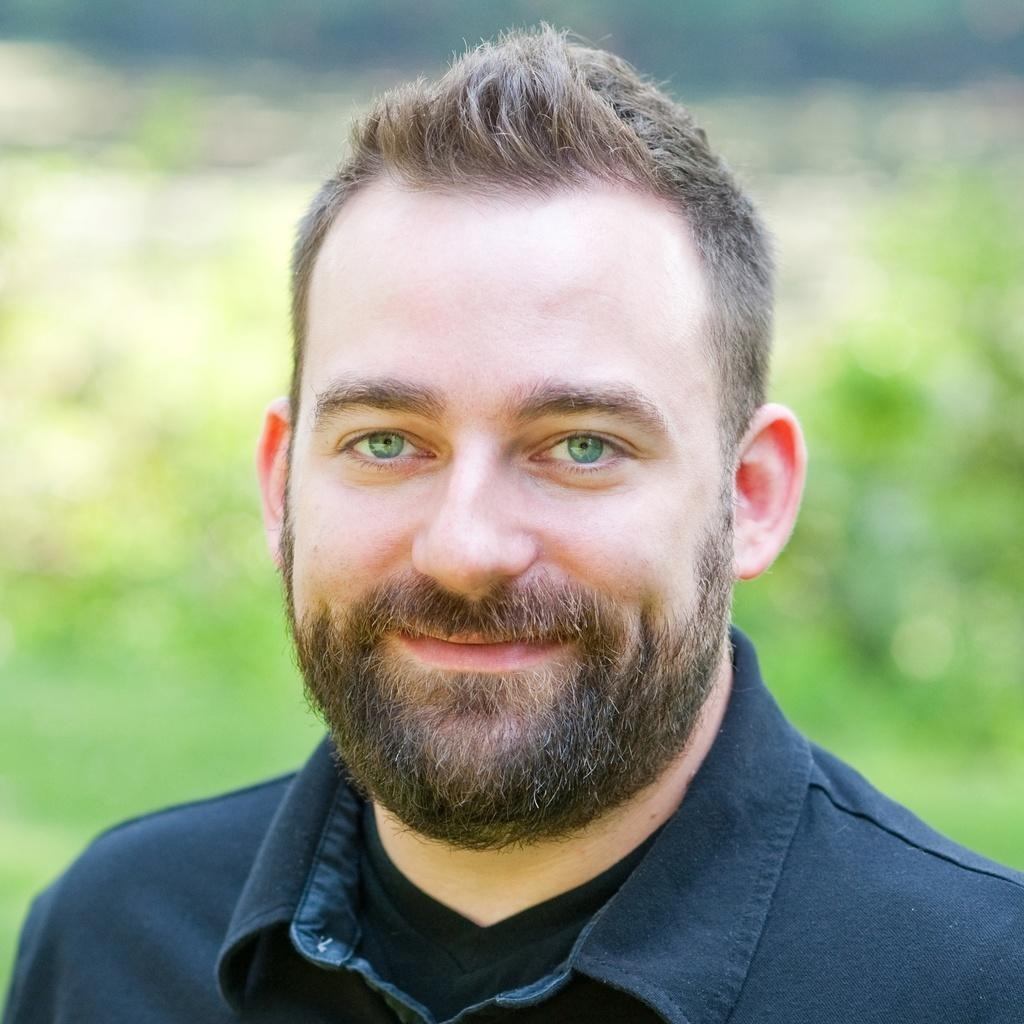Who is present in the image? There is a man present in the image. What is the man wearing? The man is wearing a blue shirt. What is the man's facial expression? The man is smiling. What facial hair does the man have? The man has a mustache and a beard. Can you describe the background of the image? The backdrop of the image is blurred. What type of soup is the man holding in the image? There is no soup present in the image; the man is not holding anything. What is the man doing with the potato in the image? There is no potato present in the image; the man is not interacting with any potatoes. 